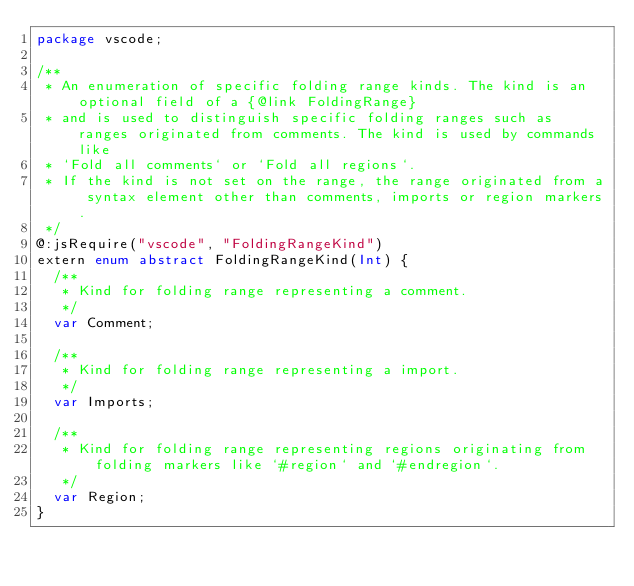<code> <loc_0><loc_0><loc_500><loc_500><_Haxe_>package vscode;

/**
 * An enumeration of specific folding range kinds. The kind is an optional field of a {@link FoldingRange}
 * and is used to distinguish specific folding ranges such as ranges originated from comments. The kind is used by commands like
 * `Fold all comments` or `Fold all regions`.
 * If the kind is not set on the range, the range originated from a syntax element other than comments, imports or region markers.
 */
@:jsRequire("vscode", "FoldingRangeKind")
extern enum abstract FoldingRangeKind(Int) {
	/**
	 * Kind for folding range representing a comment.
	 */
	var Comment;

	/**
	 * Kind for folding range representing a import.
	 */
	var Imports;

	/**
	 * Kind for folding range representing regions originating from folding markers like `#region` and `#endregion`.
	 */
	var Region;
}
</code> 